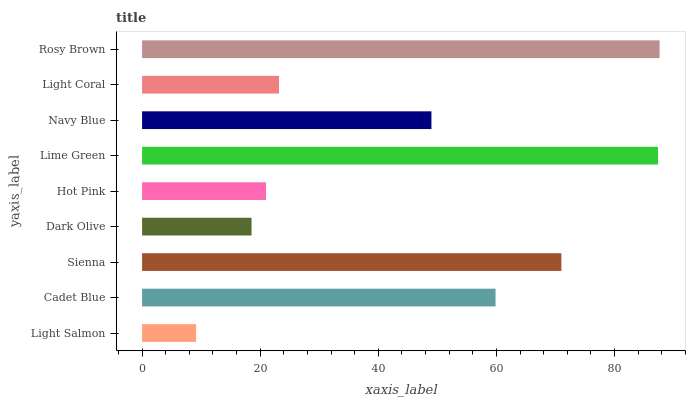Is Light Salmon the minimum?
Answer yes or no. Yes. Is Rosy Brown the maximum?
Answer yes or no. Yes. Is Cadet Blue the minimum?
Answer yes or no. No. Is Cadet Blue the maximum?
Answer yes or no. No. Is Cadet Blue greater than Light Salmon?
Answer yes or no. Yes. Is Light Salmon less than Cadet Blue?
Answer yes or no. Yes. Is Light Salmon greater than Cadet Blue?
Answer yes or no. No. Is Cadet Blue less than Light Salmon?
Answer yes or no. No. Is Navy Blue the high median?
Answer yes or no. Yes. Is Navy Blue the low median?
Answer yes or no. Yes. Is Cadet Blue the high median?
Answer yes or no. No. Is Rosy Brown the low median?
Answer yes or no. No. 